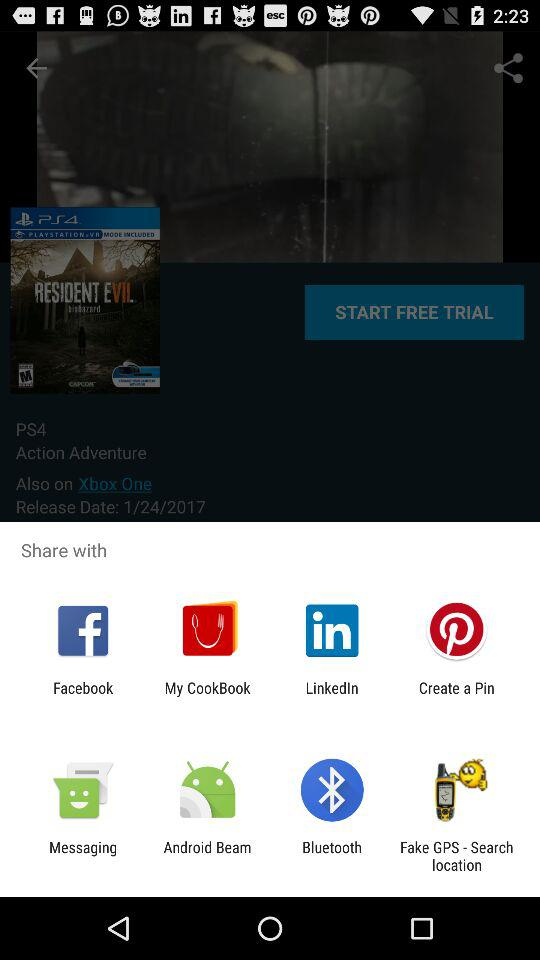How many days does the free trial last?
When the provided information is insufficient, respond with <no answer>. <no answer> 